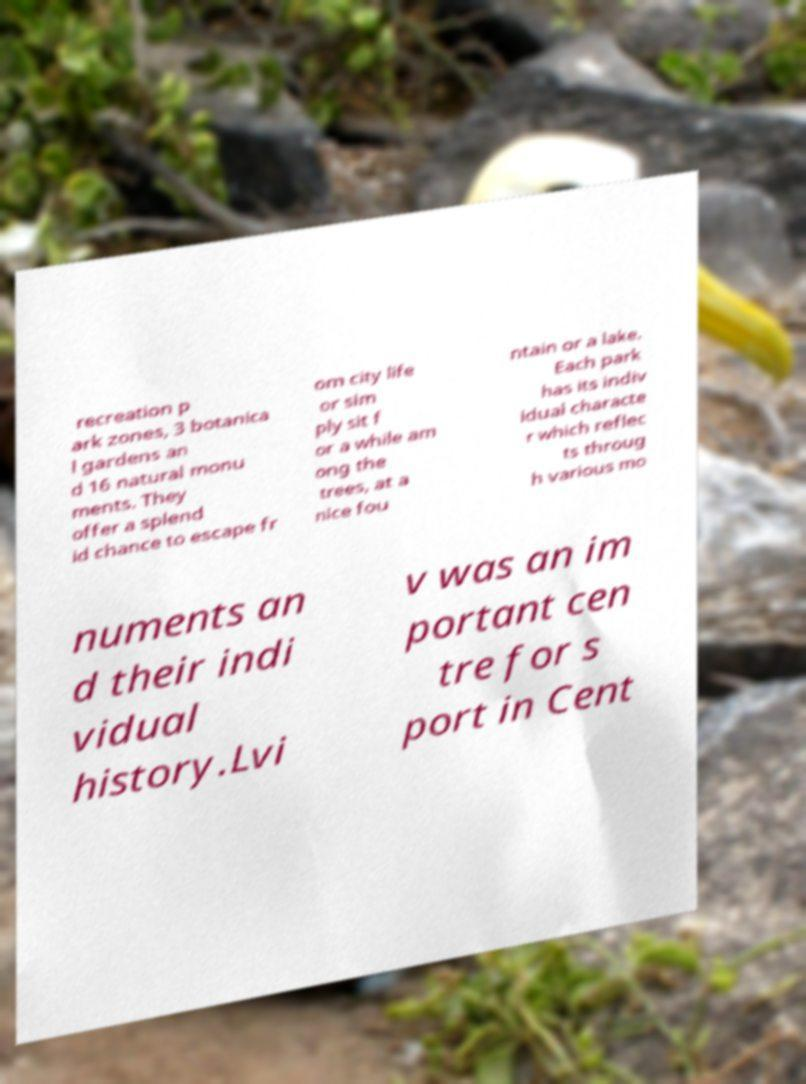Can you read and provide the text displayed in the image?This photo seems to have some interesting text. Can you extract and type it out for me? recreation p ark zones, 3 botanica l gardens an d 16 natural monu ments. They offer a splend id chance to escape fr om city life or sim ply sit f or a while am ong the trees, at a nice fou ntain or a lake. Each park has its indiv idual characte r which reflec ts throug h various mo numents an d their indi vidual history.Lvi v was an im portant cen tre for s port in Cent 